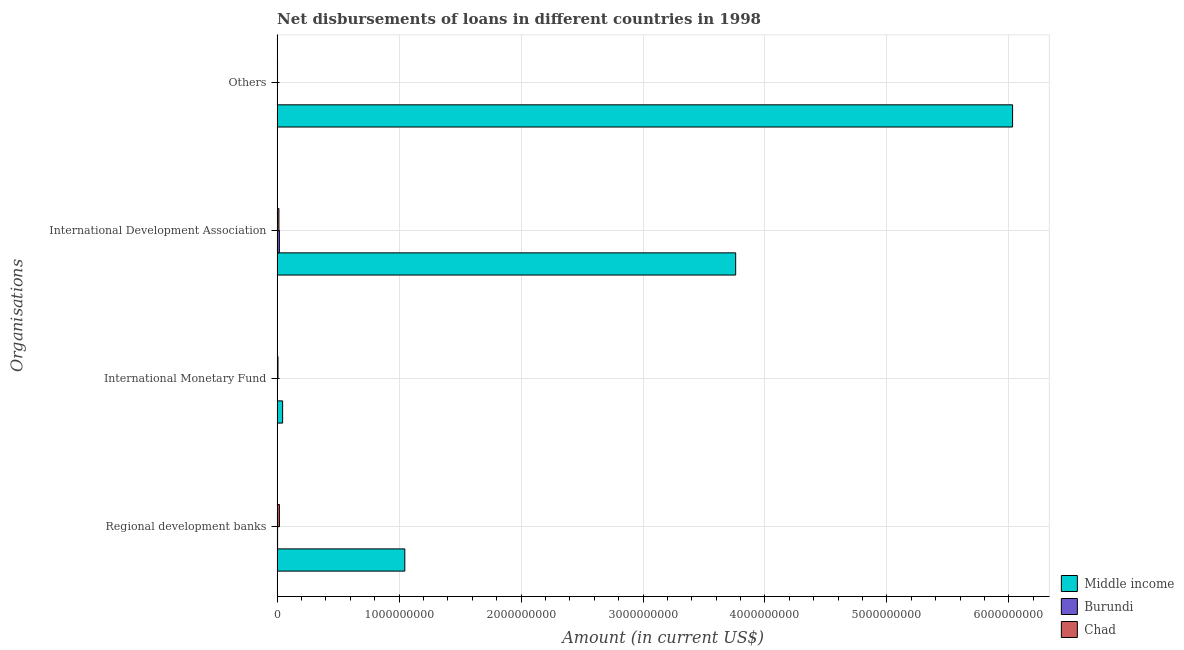Are the number of bars per tick equal to the number of legend labels?
Offer a very short reply. No. How many bars are there on the 4th tick from the bottom?
Ensure brevity in your answer.  2. What is the label of the 3rd group of bars from the top?
Your answer should be very brief. International Monetary Fund. What is the amount of loan disimbursed by regional development banks in Burundi?
Make the answer very short. 3.83e+06. Across all countries, what is the maximum amount of loan disimbursed by other organisations?
Offer a very short reply. 6.03e+09. Across all countries, what is the minimum amount of loan disimbursed by regional development banks?
Your answer should be compact. 3.83e+06. In which country was the amount of loan disimbursed by other organisations maximum?
Your answer should be compact. Middle income. What is the total amount of loan disimbursed by other organisations in the graph?
Give a very brief answer. 6.03e+09. What is the difference between the amount of loan disimbursed by international monetary fund in Middle income and that in Chad?
Provide a succinct answer. 3.81e+07. What is the difference between the amount of loan disimbursed by international monetary fund in Chad and the amount of loan disimbursed by other organisations in Middle income?
Your answer should be compact. -6.02e+09. What is the average amount of loan disimbursed by international development association per country?
Ensure brevity in your answer.  1.26e+09. What is the difference between the amount of loan disimbursed by international monetary fund and amount of loan disimbursed by international development association in Middle income?
Your answer should be compact. -3.71e+09. In how many countries, is the amount of loan disimbursed by international development association greater than 1600000000 US$?
Your answer should be compact. 1. What is the ratio of the amount of loan disimbursed by international development association in Chad to that in Middle income?
Keep it short and to the point. 0. What is the difference between the highest and the second highest amount of loan disimbursed by regional development banks?
Make the answer very short. 1.03e+09. What is the difference between the highest and the lowest amount of loan disimbursed by international development association?
Your answer should be compact. 3.75e+09. In how many countries, is the amount of loan disimbursed by other organisations greater than the average amount of loan disimbursed by other organisations taken over all countries?
Your answer should be compact. 1. Is it the case that in every country, the sum of the amount of loan disimbursed by regional development banks and amount of loan disimbursed by international monetary fund is greater than the amount of loan disimbursed by international development association?
Your response must be concise. No. Are the values on the major ticks of X-axis written in scientific E-notation?
Offer a terse response. No. Does the graph contain any zero values?
Give a very brief answer. Yes. Where does the legend appear in the graph?
Give a very brief answer. Bottom right. How many legend labels are there?
Offer a terse response. 3. What is the title of the graph?
Make the answer very short. Net disbursements of loans in different countries in 1998. Does "Namibia" appear as one of the legend labels in the graph?
Make the answer very short. No. What is the label or title of the Y-axis?
Ensure brevity in your answer.  Organisations. What is the Amount (in current US$) of Middle income in Regional development banks?
Your answer should be compact. 1.05e+09. What is the Amount (in current US$) in Burundi in Regional development banks?
Your answer should be compact. 3.83e+06. What is the Amount (in current US$) in Chad in Regional development banks?
Offer a terse response. 1.86e+07. What is the Amount (in current US$) of Middle income in International Monetary Fund?
Your response must be concise. 4.51e+07. What is the Amount (in current US$) of Chad in International Monetary Fund?
Your answer should be compact. 7.06e+06. What is the Amount (in current US$) of Middle income in International Development Association?
Your response must be concise. 3.76e+09. What is the Amount (in current US$) of Burundi in International Development Association?
Your response must be concise. 1.85e+07. What is the Amount (in current US$) in Chad in International Development Association?
Offer a very short reply. 1.47e+07. What is the Amount (in current US$) of Middle income in Others?
Your response must be concise. 6.03e+09. What is the Amount (in current US$) in Burundi in Others?
Keep it short and to the point. 0. What is the Amount (in current US$) of Chad in Others?
Your answer should be compact. 3.31e+06. Across all Organisations, what is the maximum Amount (in current US$) in Middle income?
Ensure brevity in your answer.  6.03e+09. Across all Organisations, what is the maximum Amount (in current US$) of Burundi?
Give a very brief answer. 1.85e+07. Across all Organisations, what is the maximum Amount (in current US$) in Chad?
Keep it short and to the point. 1.86e+07. Across all Organisations, what is the minimum Amount (in current US$) in Middle income?
Your answer should be compact. 4.51e+07. Across all Organisations, what is the minimum Amount (in current US$) in Burundi?
Provide a short and direct response. 0. Across all Organisations, what is the minimum Amount (in current US$) in Chad?
Keep it short and to the point. 3.31e+06. What is the total Amount (in current US$) of Middle income in the graph?
Make the answer very short. 1.09e+1. What is the total Amount (in current US$) of Burundi in the graph?
Give a very brief answer. 2.23e+07. What is the total Amount (in current US$) of Chad in the graph?
Your response must be concise. 4.37e+07. What is the difference between the Amount (in current US$) of Middle income in Regional development banks and that in International Monetary Fund?
Ensure brevity in your answer.  1.00e+09. What is the difference between the Amount (in current US$) of Chad in Regional development banks and that in International Monetary Fund?
Offer a very short reply. 1.15e+07. What is the difference between the Amount (in current US$) of Middle income in Regional development banks and that in International Development Association?
Your answer should be very brief. -2.71e+09. What is the difference between the Amount (in current US$) of Burundi in Regional development banks and that in International Development Association?
Give a very brief answer. -1.46e+07. What is the difference between the Amount (in current US$) in Chad in Regional development banks and that in International Development Association?
Offer a terse response. 3.82e+06. What is the difference between the Amount (in current US$) of Middle income in Regional development banks and that in Others?
Give a very brief answer. -4.98e+09. What is the difference between the Amount (in current US$) of Chad in Regional development banks and that in Others?
Offer a very short reply. 1.53e+07. What is the difference between the Amount (in current US$) in Middle income in International Monetary Fund and that in International Development Association?
Your answer should be compact. -3.71e+09. What is the difference between the Amount (in current US$) in Chad in International Monetary Fund and that in International Development Association?
Provide a succinct answer. -7.69e+06. What is the difference between the Amount (in current US$) in Middle income in International Monetary Fund and that in Others?
Provide a short and direct response. -5.99e+09. What is the difference between the Amount (in current US$) in Chad in International Monetary Fund and that in Others?
Offer a very short reply. 3.75e+06. What is the difference between the Amount (in current US$) in Middle income in International Development Association and that in Others?
Your answer should be very brief. -2.27e+09. What is the difference between the Amount (in current US$) in Chad in International Development Association and that in Others?
Give a very brief answer. 1.14e+07. What is the difference between the Amount (in current US$) in Middle income in Regional development banks and the Amount (in current US$) in Chad in International Monetary Fund?
Ensure brevity in your answer.  1.04e+09. What is the difference between the Amount (in current US$) in Burundi in Regional development banks and the Amount (in current US$) in Chad in International Monetary Fund?
Provide a succinct answer. -3.22e+06. What is the difference between the Amount (in current US$) of Middle income in Regional development banks and the Amount (in current US$) of Burundi in International Development Association?
Keep it short and to the point. 1.03e+09. What is the difference between the Amount (in current US$) of Middle income in Regional development banks and the Amount (in current US$) of Chad in International Development Association?
Give a very brief answer. 1.03e+09. What is the difference between the Amount (in current US$) in Burundi in Regional development banks and the Amount (in current US$) in Chad in International Development Association?
Your answer should be very brief. -1.09e+07. What is the difference between the Amount (in current US$) of Middle income in Regional development banks and the Amount (in current US$) of Chad in Others?
Offer a terse response. 1.04e+09. What is the difference between the Amount (in current US$) of Burundi in Regional development banks and the Amount (in current US$) of Chad in Others?
Your response must be concise. 5.24e+05. What is the difference between the Amount (in current US$) in Middle income in International Monetary Fund and the Amount (in current US$) in Burundi in International Development Association?
Ensure brevity in your answer.  2.67e+07. What is the difference between the Amount (in current US$) of Middle income in International Monetary Fund and the Amount (in current US$) of Chad in International Development Association?
Your response must be concise. 3.04e+07. What is the difference between the Amount (in current US$) in Middle income in International Monetary Fund and the Amount (in current US$) in Chad in Others?
Your response must be concise. 4.18e+07. What is the difference between the Amount (in current US$) of Middle income in International Development Association and the Amount (in current US$) of Chad in Others?
Give a very brief answer. 3.76e+09. What is the difference between the Amount (in current US$) in Burundi in International Development Association and the Amount (in current US$) in Chad in Others?
Your response must be concise. 1.52e+07. What is the average Amount (in current US$) of Middle income per Organisations?
Give a very brief answer. 2.72e+09. What is the average Amount (in current US$) in Burundi per Organisations?
Give a very brief answer. 5.58e+06. What is the average Amount (in current US$) in Chad per Organisations?
Make the answer very short. 1.09e+07. What is the difference between the Amount (in current US$) in Middle income and Amount (in current US$) in Burundi in Regional development banks?
Give a very brief answer. 1.04e+09. What is the difference between the Amount (in current US$) of Middle income and Amount (in current US$) of Chad in Regional development banks?
Provide a succinct answer. 1.03e+09. What is the difference between the Amount (in current US$) of Burundi and Amount (in current US$) of Chad in Regional development banks?
Give a very brief answer. -1.47e+07. What is the difference between the Amount (in current US$) of Middle income and Amount (in current US$) of Chad in International Monetary Fund?
Provide a short and direct response. 3.81e+07. What is the difference between the Amount (in current US$) of Middle income and Amount (in current US$) of Burundi in International Development Association?
Make the answer very short. 3.74e+09. What is the difference between the Amount (in current US$) in Middle income and Amount (in current US$) in Chad in International Development Association?
Keep it short and to the point. 3.75e+09. What is the difference between the Amount (in current US$) in Burundi and Amount (in current US$) in Chad in International Development Association?
Provide a short and direct response. 3.74e+06. What is the difference between the Amount (in current US$) in Middle income and Amount (in current US$) in Chad in Others?
Give a very brief answer. 6.03e+09. What is the ratio of the Amount (in current US$) of Middle income in Regional development banks to that in International Monetary Fund?
Offer a terse response. 23.19. What is the ratio of the Amount (in current US$) of Chad in Regional development banks to that in International Monetary Fund?
Offer a very short reply. 2.63. What is the ratio of the Amount (in current US$) in Middle income in Regional development banks to that in International Development Association?
Your answer should be very brief. 0.28. What is the ratio of the Amount (in current US$) in Burundi in Regional development banks to that in International Development Association?
Give a very brief answer. 0.21. What is the ratio of the Amount (in current US$) in Chad in Regional development banks to that in International Development Association?
Give a very brief answer. 1.26. What is the ratio of the Amount (in current US$) of Middle income in Regional development banks to that in Others?
Provide a succinct answer. 0.17. What is the ratio of the Amount (in current US$) of Chad in Regional development banks to that in Others?
Offer a very short reply. 5.61. What is the ratio of the Amount (in current US$) in Middle income in International Monetary Fund to that in International Development Association?
Your response must be concise. 0.01. What is the ratio of the Amount (in current US$) in Chad in International Monetary Fund to that in International Development Association?
Offer a terse response. 0.48. What is the ratio of the Amount (in current US$) of Middle income in International Monetary Fund to that in Others?
Offer a terse response. 0.01. What is the ratio of the Amount (in current US$) of Chad in International Monetary Fund to that in Others?
Ensure brevity in your answer.  2.13. What is the ratio of the Amount (in current US$) of Middle income in International Development Association to that in Others?
Your answer should be compact. 0.62. What is the ratio of the Amount (in current US$) of Chad in International Development Association to that in Others?
Make the answer very short. 4.46. What is the difference between the highest and the second highest Amount (in current US$) of Middle income?
Give a very brief answer. 2.27e+09. What is the difference between the highest and the second highest Amount (in current US$) in Chad?
Provide a short and direct response. 3.82e+06. What is the difference between the highest and the lowest Amount (in current US$) of Middle income?
Keep it short and to the point. 5.99e+09. What is the difference between the highest and the lowest Amount (in current US$) of Burundi?
Ensure brevity in your answer.  1.85e+07. What is the difference between the highest and the lowest Amount (in current US$) of Chad?
Provide a short and direct response. 1.53e+07. 